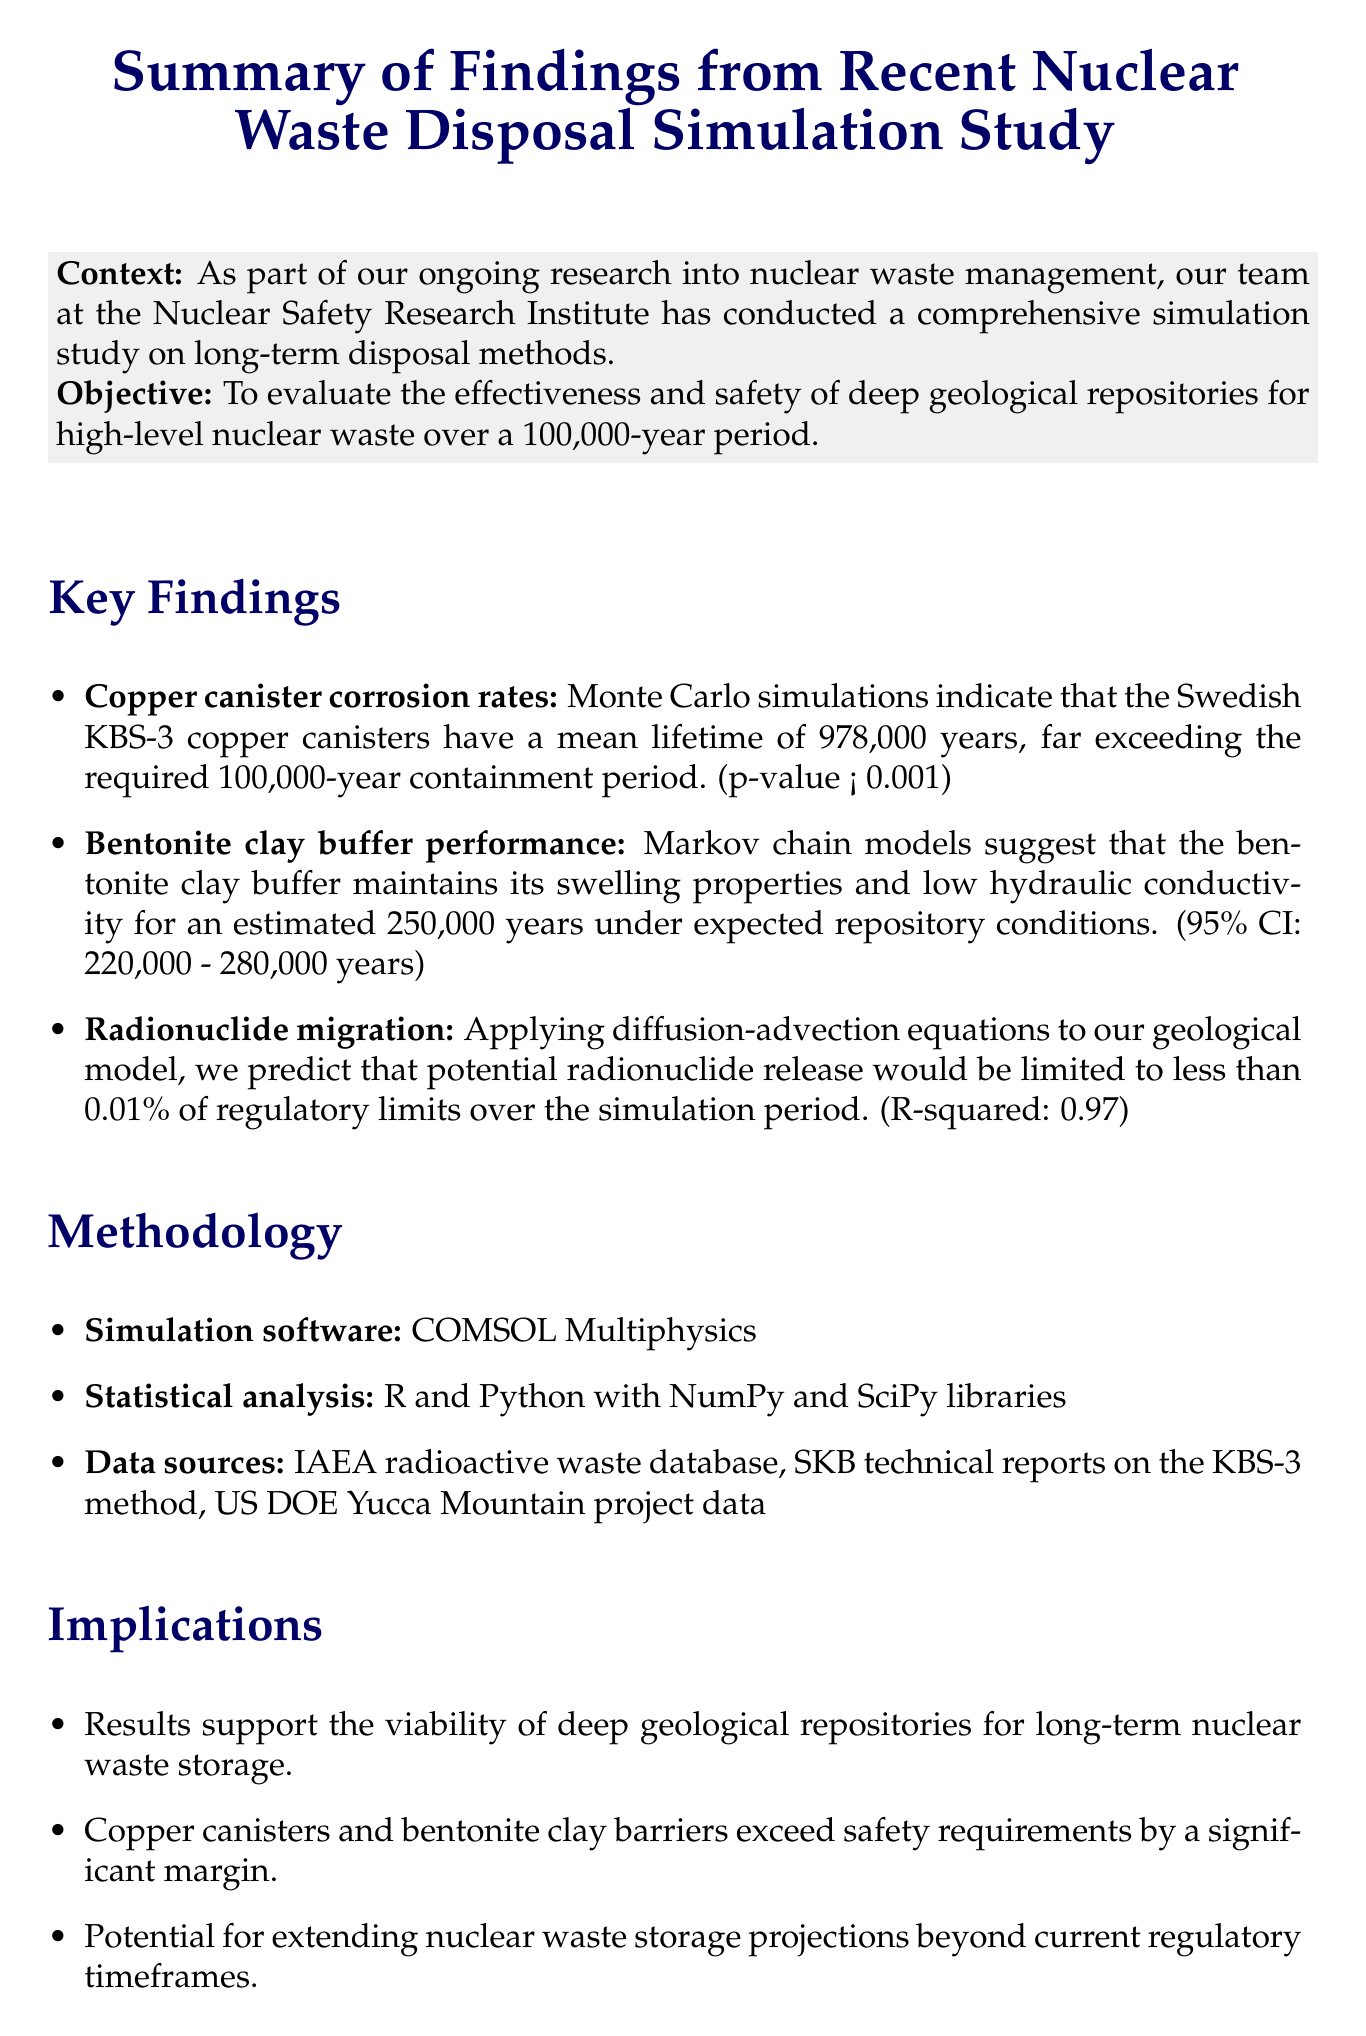What is the main objective of the study? The objective is to evaluate the effectiveness and safety of deep geological repositories for high-level nuclear waste over a 100,000-year period.
Answer: To evaluate the effectiveness and safety of deep geological repositories for high-level nuclear waste over a 100,000-year period What is the mean lifetime of the Swedish KBS-3 copper canisters? The mean lifetime of the canisters is found through Monte Carlo simulations.
Answer: 978,000 years What is the 95% confidence interval for the bentonite clay buffer performance? The confidence interval indicates the range of estimated years the bentonite clay will perform under expected conditions.
Answer: 220,000 - 280,000 years What statistical method was used to analyze radionuclide migration? The document mentions the specific equation applied to the geological model for this analysis.
Answer: Diffusion-advection equations Which simulation software was used in the study? The simulation software is crucial for carrying out the simulations in the research.
Answer: COMSOL Multiphysics What are the main recommendations given in the memo? The memo provides suggestions based on the study results aimed at improving future research and collaborations.
Answer: Continue research on alternative canister materials What does the document conclude about the repository system's performance? The conclusion summarizes the findings regarding the system's capacity to contain nuclear waste.
Answer: The robust performance of the simulated deep geological repository system What is the expected next step mentioned in the memo? The next step indicates the planned future actions regarding the research findings.
Answer: Present findings at the upcoming American Nuclear Society Annual Meeting 